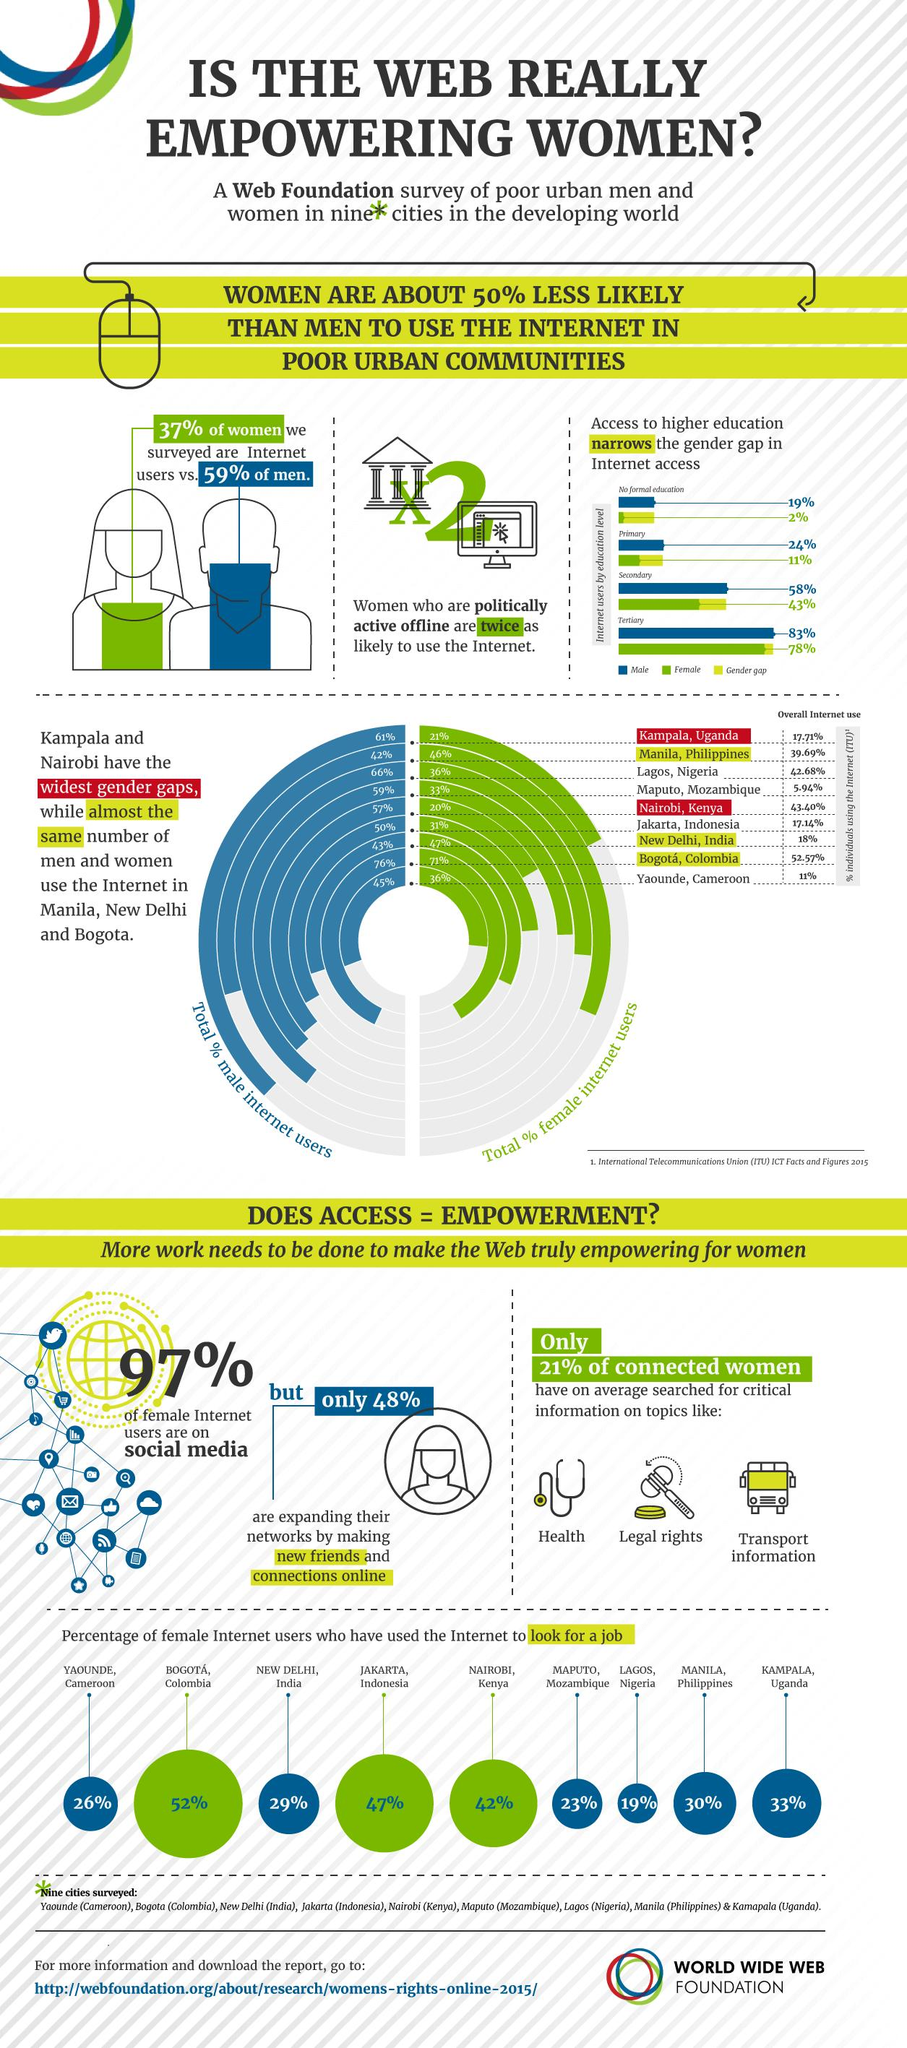List a handful of essential elements in this visual. People with no formal education have the highest gender gap in internet access. According to the given information, approximately 11% of individuals who have primary education and internet access are female. In the world, there are individuals who are not able to access the internet due to a gender gap of 15% in internet access, specifically those in the secondary education level. In Lagos, Nigeria, female internet users are among those who are least likely to be searching for a job online. It is evident that men use the internet more than women. 